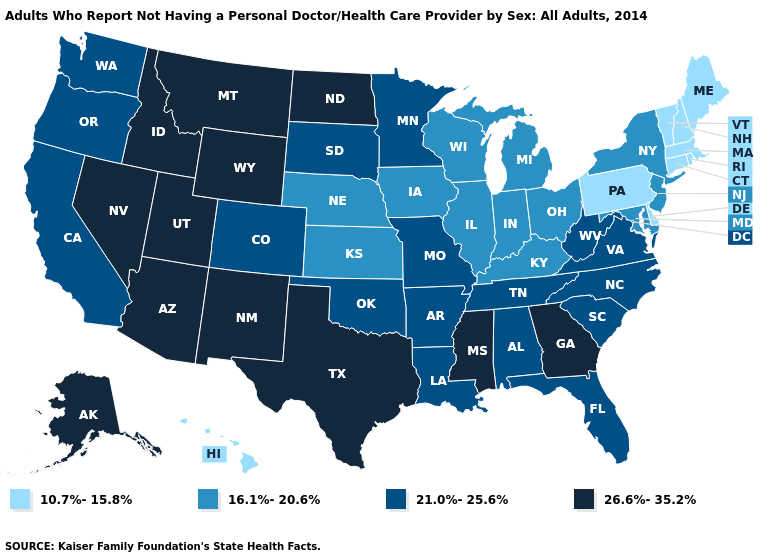Name the states that have a value in the range 10.7%-15.8%?
Concise answer only. Connecticut, Delaware, Hawaii, Maine, Massachusetts, New Hampshire, Pennsylvania, Rhode Island, Vermont. Name the states that have a value in the range 16.1%-20.6%?
Answer briefly. Illinois, Indiana, Iowa, Kansas, Kentucky, Maryland, Michigan, Nebraska, New Jersey, New York, Ohio, Wisconsin. Name the states that have a value in the range 21.0%-25.6%?
Concise answer only. Alabama, Arkansas, California, Colorado, Florida, Louisiana, Minnesota, Missouri, North Carolina, Oklahoma, Oregon, South Carolina, South Dakota, Tennessee, Virginia, Washington, West Virginia. Does Arkansas have the same value as South Carolina?
Answer briefly. Yes. Name the states that have a value in the range 16.1%-20.6%?
Keep it brief. Illinois, Indiana, Iowa, Kansas, Kentucky, Maryland, Michigan, Nebraska, New Jersey, New York, Ohio, Wisconsin. Among the states that border Maryland , does Pennsylvania have the highest value?
Give a very brief answer. No. Does Illinois have the lowest value in the USA?
Write a very short answer. No. Does the map have missing data?
Answer briefly. No. What is the value of Connecticut?
Give a very brief answer. 10.7%-15.8%. What is the highest value in the Northeast ?
Write a very short answer. 16.1%-20.6%. What is the value of Iowa?
Keep it brief. 16.1%-20.6%. Does Massachusetts have the highest value in the USA?
Answer briefly. No. Does the map have missing data?
Write a very short answer. No. Name the states that have a value in the range 16.1%-20.6%?
Short answer required. Illinois, Indiana, Iowa, Kansas, Kentucky, Maryland, Michigan, Nebraska, New Jersey, New York, Ohio, Wisconsin. Name the states that have a value in the range 21.0%-25.6%?
Write a very short answer. Alabama, Arkansas, California, Colorado, Florida, Louisiana, Minnesota, Missouri, North Carolina, Oklahoma, Oregon, South Carolina, South Dakota, Tennessee, Virginia, Washington, West Virginia. 